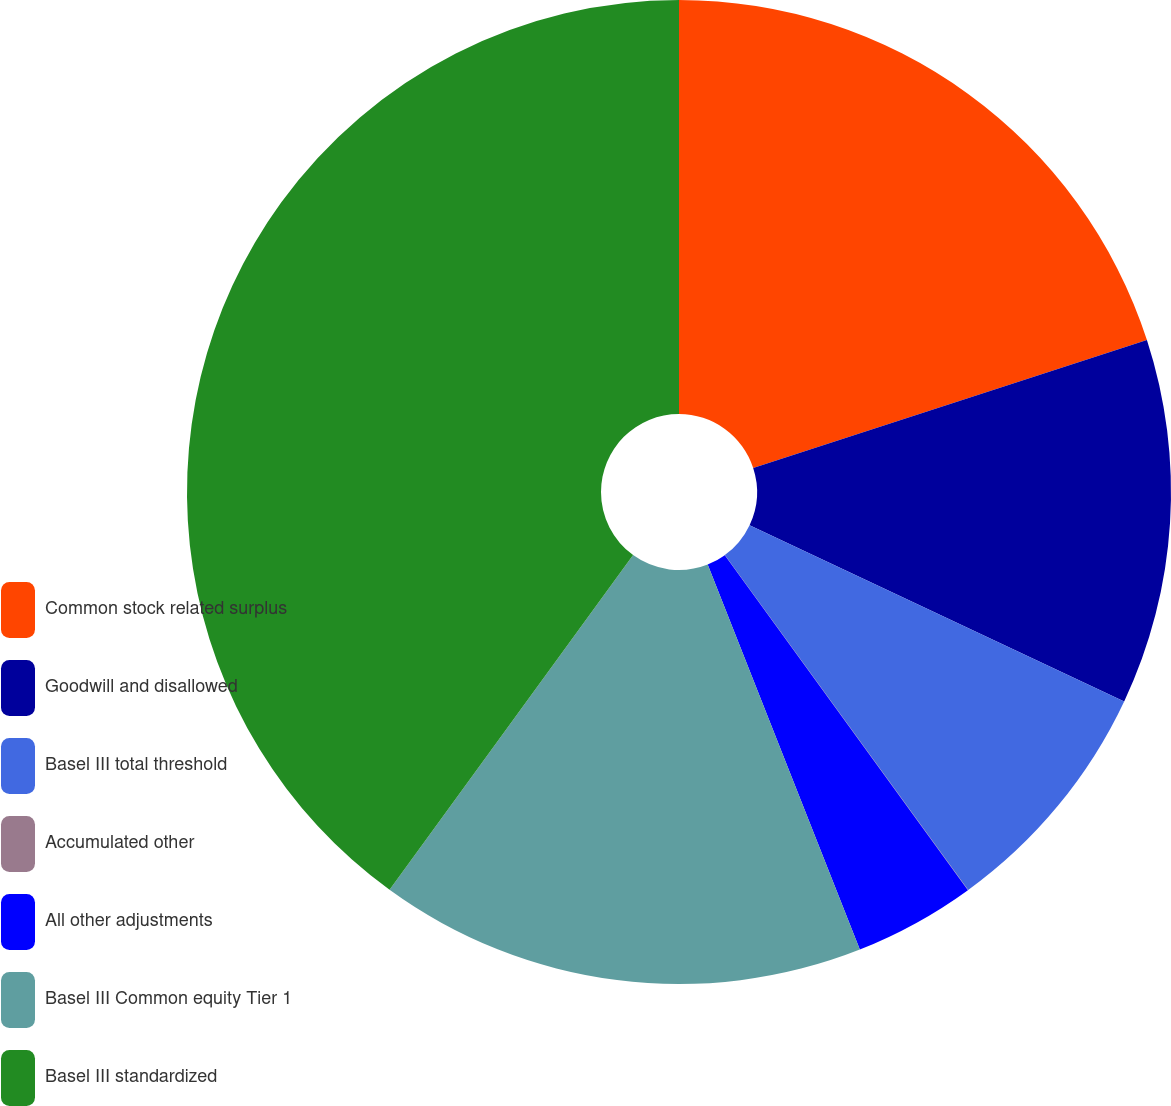<chart> <loc_0><loc_0><loc_500><loc_500><pie_chart><fcel>Common stock related surplus<fcel>Goodwill and disallowed<fcel>Basel III total threshold<fcel>Accumulated other<fcel>All other adjustments<fcel>Basel III Common equity Tier 1<fcel>Basel III standardized<nl><fcel>20.0%<fcel>12.0%<fcel>8.0%<fcel>0.01%<fcel>4.0%<fcel>16.0%<fcel>39.99%<nl></chart> 